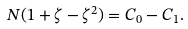Convert formula to latex. <formula><loc_0><loc_0><loc_500><loc_500>N ( 1 + \zeta - \zeta ^ { 2 } ) = C _ { 0 } - C _ { 1 } .</formula> 